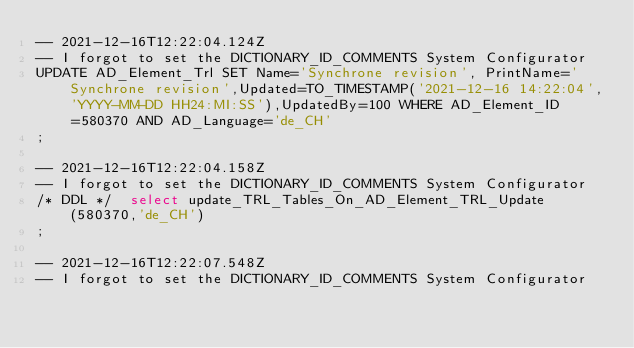<code> <loc_0><loc_0><loc_500><loc_500><_SQL_>-- 2021-12-16T12:22:04.124Z
-- I forgot to set the DICTIONARY_ID_COMMENTS System Configurator
UPDATE AD_Element_Trl SET Name='Synchrone revision', PrintName='Synchrone revision',Updated=TO_TIMESTAMP('2021-12-16 14:22:04','YYYY-MM-DD HH24:MI:SS'),UpdatedBy=100 WHERE AD_Element_ID=580370 AND AD_Language='de_CH'
;

-- 2021-12-16T12:22:04.158Z
-- I forgot to set the DICTIONARY_ID_COMMENTS System Configurator
/* DDL */  select update_TRL_Tables_On_AD_Element_TRL_Update(580370,'de_CH') 
;

-- 2021-12-16T12:22:07.548Z
-- I forgot to set the DICTIONARY_ID_COMMENTS System Configurator</code> 